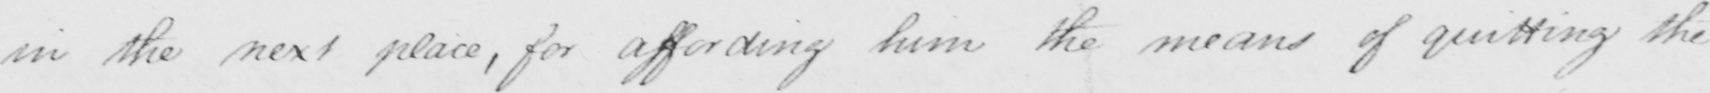What does this handwritten line say? in the next place, for affording him the means of quitting the 